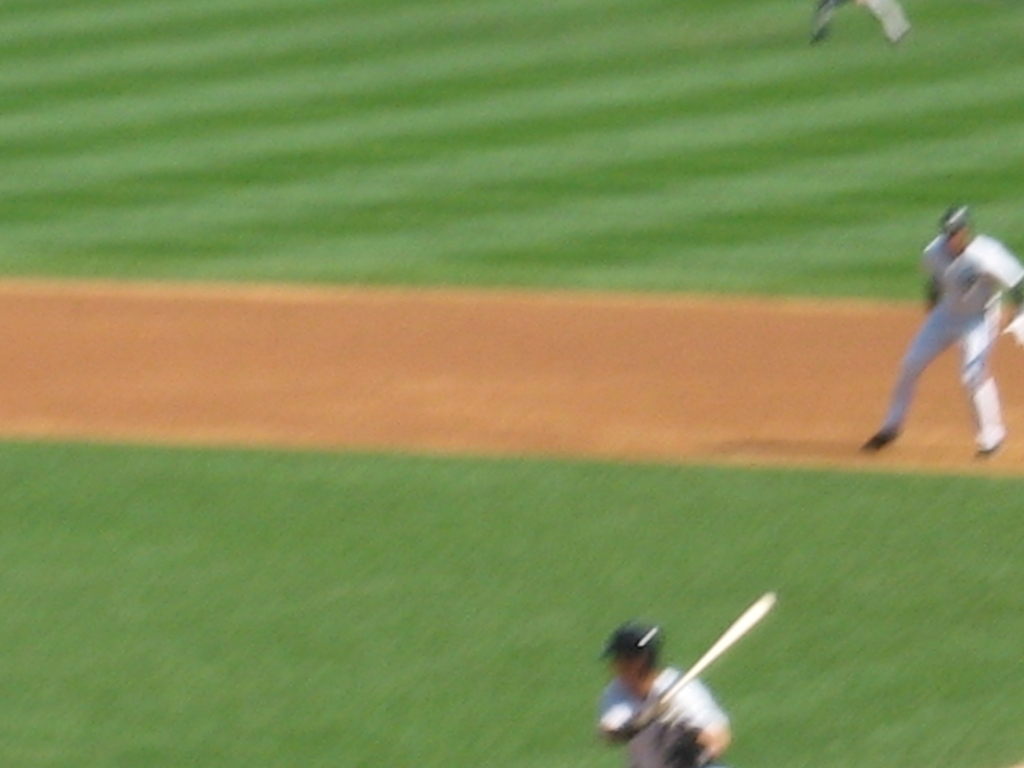How would you describe the exposure of this image? The exposure of this image is not the primary issue; rather, the image suffers from substantial motion blur, resulting in a lack of sharpness and detail. This could be due to a slow shutter speed or fast-moving subjects not being adequately captured by the camera settings. 